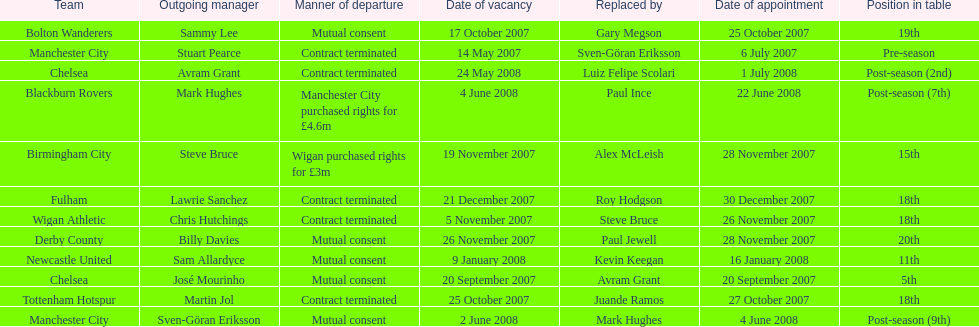What was the highest-ranked team based on their placement in the table called? Manchester City. 